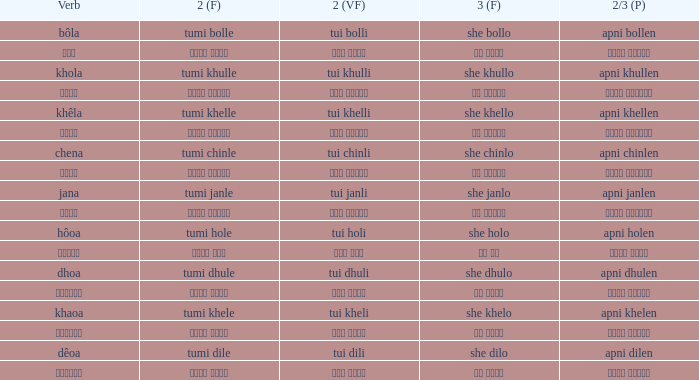What is the 2nd verb for chena? Tumi chinle. 